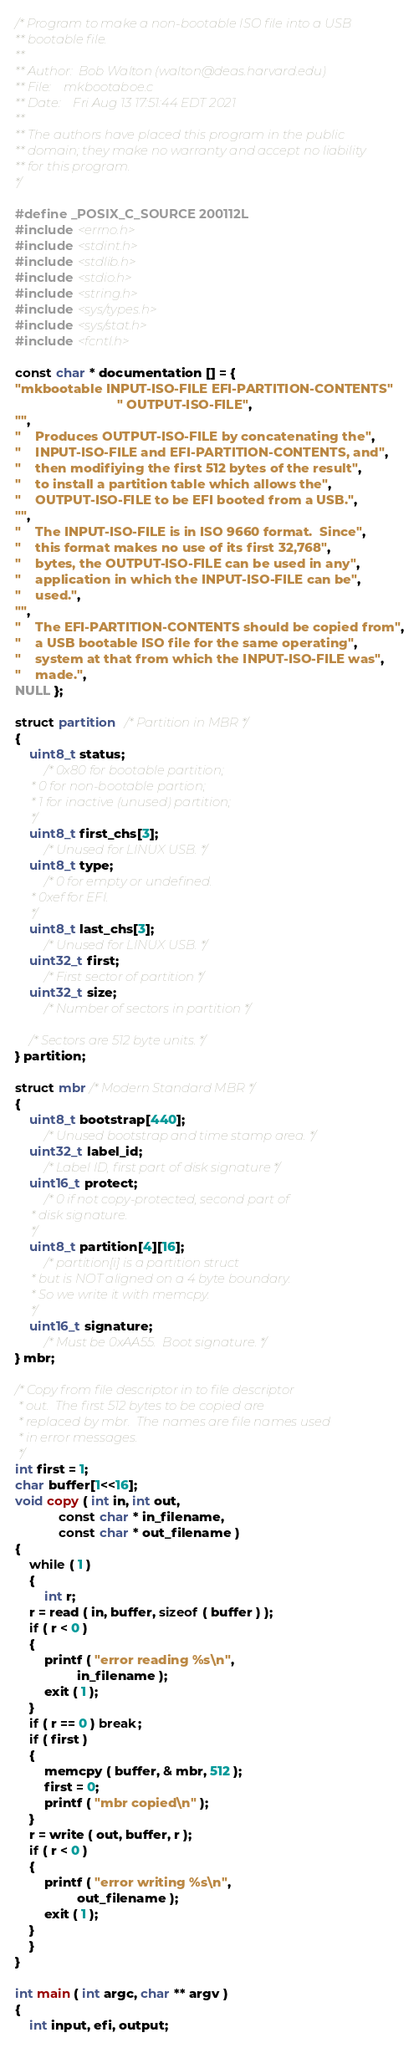<code> <loc_0><loc_0><loc_500><loc_500><_C_>/* Program to make a non-bootable ISO file into a USB
** bootable file.
**
** Author:	Bob Walton (walton@deas.harvard.edu)
** File:	mkbootaboe.c
** Date:	Fri Aug 13 17:51:44 EDT 2021
**
** The authors have placed this program in the public
** domain; they make no warranty and accept no liability
** for this program.
*/

#define _POSIX_C_SOURCE 200112L
#include <errno.h>
#include <stdint.h>
#include <stdlib.h>
#include <stdio.h>
#include <string.h>
#include <sys/types.h>
#include <sys/stat.h>
#include <fcntl.h>

const char * documentation [] = {
"mkbootable INPUT-ISO-FILE EFI-PARTITION-CONTENTS"
                            " OUTPUT-ISO-FILE",
"",
"    Produces OUTPUT-ISO-FILE by concatenating the",
"    INPUT-ISO-FILE and EFI-PARTITION-CONTENTS, and",
"    then modifiying the first 512 bytes of the result",
"    to install a partition table which allows the",
"    OUTPUT-ISO-FILE to be EFI booted from a USB.",
"",
"    The INPUT-ISO-FILE is in ISO 9660 format.  Since",
"    this format makes no use of its first 32,768",
"    bytes, the OUTPUT-ISO-FILE can be used in any",
"    application in which the INPUT-ISO-FILE can be",
"    used.",
"",
"    The EFI-PARTITION-CONTENTS should be copied from",
"    a USB bootable ISO file for the same operating",
"    system at that from which the INPUT-ISO-FILE was",
"    made.",
NULL };

struct partition  /* Partition in MBR */
{
    uint8_t status;
        /* 0x80 for bootable partition;
	 * 0 for non-bootable partion;
	 * 1 for inactive (unused) partition;
	 */
    uint8_t first_chs[3];
        /* Unused for LINUX USB. */
    uint8_t type;
        /* 0 for empty or undefined.
	 * 0xef for EFI.
	 */
    uint8_t last_chs[3];
        /* Unused for LINUX USB. */
    uint32_t first;
        /* First sector of partition */
    uint32_t size;
        /* Number of sectors in partition */

    /* Sectors are 512 byte units. */
} partition;

struct mbr /* Modern Standard MBR */
{
    uint8_t bootstrap[440];
        /* Unused bootstrap and time stamp area. */
    uint32_t label_id;
        /* Label ID, first part of disk signature */
    uint16_t protect;
        /* 0 if not copy-protected, second part of
	 * disk signature.
	 */
    uint8_t partition[4][16];
        /* partition[i] is a partition struct
	 * but is NOT aligned on a 4 byte boundary.
	 * So we write it with memcpy.
	 */
    uint16_t signature;
        /* Must be 0xAA55.  Boot signature. */
} mbr;

/* Copy from file descriptor in to file descriptor
 * out.  The first 512 bytes to be copied are
 * replaced by mbr.  The names are file names used
 * in error messages.
 */
int first = 1;
char buffer[1<<16];
void copy ( int in, int out,
            const char * in_filename,
            const char * out_filename )
{
    while ( 1 )
    {
        int r;
	r = read ( in, buffer, sizeof ( buffer ) );
	if ( r < 0 )
	{
	    printf ( "error reading %s\n",
	             in_filename );
	    exit ( 1 );
	}
	if ( r == 0 ) break;
	if ( first )
	{
	    memcpy ( buffer, & mbr, 512 );
	    first = 0;
	    printf ( "mbr copied\n" );
	}
	r = write ( out, buffer, r );
	if ( r < 0 )
	{
	    printf ( "error writing %s\n",
	             out_filename );
	    exit ( 1 );
	}
    }
}

int main ( int argc, char ** argv )
{
    int input, efi, output;</code> 